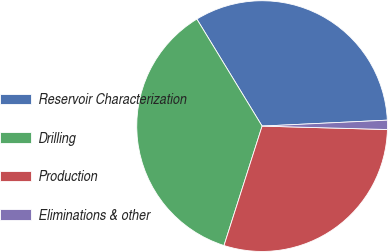<chart> <loc_0><loc_0><loc_500><loc_500><pie_chart><fcel>Reservoir Characterization<fcel>Drilling<fcel>Production<fcel>Eliminations & other<nl><fcel>32.96%<fcel>36.37%<fcel>29.48%<fcel>1.19%<nl></chart> 